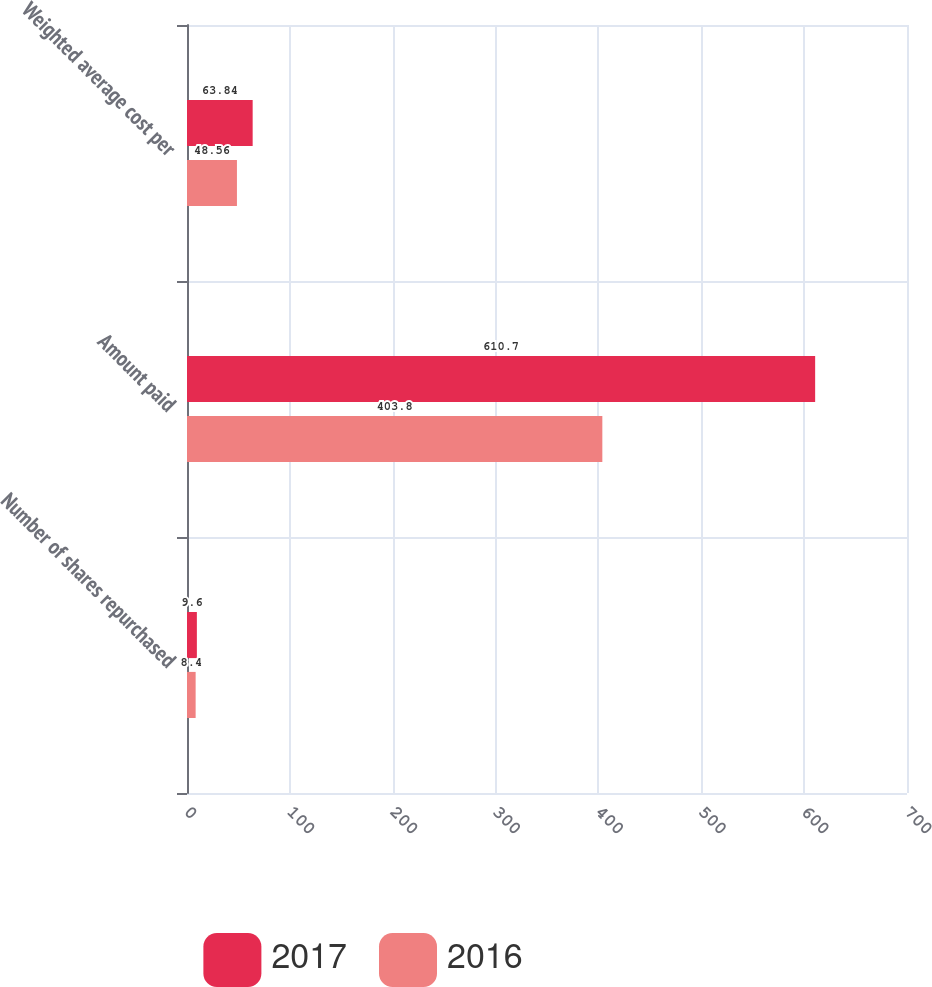Convert chart. <chart><loc_0><loc_0><loc_500><loc_500><stacked_bar_chart><ecel><fcel>Number of shares repurchased<fcel>Amount paid<fcel>Weighted average cost per<nl><fcel>2017<fcel>9.6<fcel>610.7<fcel>63.84<nl><fcel>2016<fcel>8.4<fcel>403.8<fcel>48.56<nl></chart> 